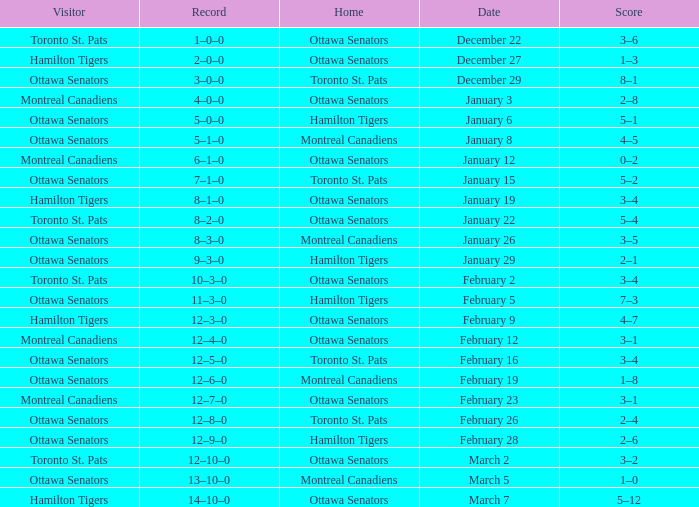Could you parse the entire table? {'header': ['Visitor', 'Record', 'Home', 'Date', 'Score'], 'rows': [['Toronto St. Pats', '1–0–0', 'Ottawa Senators', 'December 22', '3–6'], ['Hamilton Tigers', '2–0–0', 'Ottawa Senators', 'December 27', '1–3'], ['Ottawa Senators', '3–0–0', 'Toronto St. Pats', 'December 29', '8–1'], ['Montreal Canadiens', '4–0–0', 'Ottawa Senators', 'January 3', '2–8'], ['Ottawa Senators', '5–0–0', 'Hamilton Tigers', 'January 6', '5–1'], ['Ottawa Senators', '5–1–0', 'Montreal Canadiens', 'January 8', '4–5'], ['Montreal Canadiens', '6–1–0', 'Ottawa Senators', 'January 12', '0–2'], ['Ottawa Senators', '7–1–0', 'Toronto St. Pats', 'January 15', '5–2'], ['Hamilton Tigers', '8–1–0', 'Ottawa Senators', 'January 19', '3–4'], ['Toronto St. Pats', '8–2–0', 'Ottawa Senators', 'January 22', '5–4'], ['Ottawa Senators', '8–3–0', 'Montreal Canadiens', 'January 26', '3–5'], ['Ottawa Senators', '9–3–0', 'Hamilton Tigers', 'January 29', '2–1'], ['Toronto St. Pats', '10–3–0', 'Ottawa Senators', 'February 2', '3–4'], ['Ottawa Senators', '11–3–0', 'Hamilton Tigers', 'February 5', '7–3'], ['Hamilton Tigers', '12–3–0', 'Ottawa Senators', 'February 9', '4–7'], ['Montreal Canadiens', '12–4–0', 'Ottawa Senators', 'February 12', '3–1'], ['Ottawa Senators', '12–5–0', 'Toronto St. Pats', 'February 16', '3–4'], ['Ottawa Senators', '12–6–0', 'Montreal Canadiens', 'February 19', '1–8'], ['Montreal Canadiens', '12–7–0', 'Ottawa Senators', 'February 23', '3–1'], ['Ottawa Senators', '12–8–0', 'Toronto St. Pats', 'February 26', '2–4'], ['Ottawa Senators', '12–9–0', 'Hamilton Tigers', 'February 28', '2–6'], ['Toronto St. Pats', '12–10–0', 'Ottawa Senators', 'March 2', '3–2'], ['Ottawa Senators', '13–10–0', 'Montreal Canadiens', 'March 5', '1–0'], ['Hamilton Tigers', '14–10–0', 'Ottawa Senators', 'March 7', '5–12']]} What is the score of the game on January 12? 0–2. 